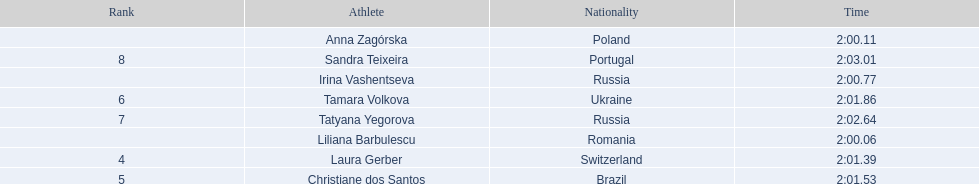Who came in second place at the athletics at the 2003 summer universiade - women's 800 metres? Anna Zagórska. What was her time? 2:00.11. 